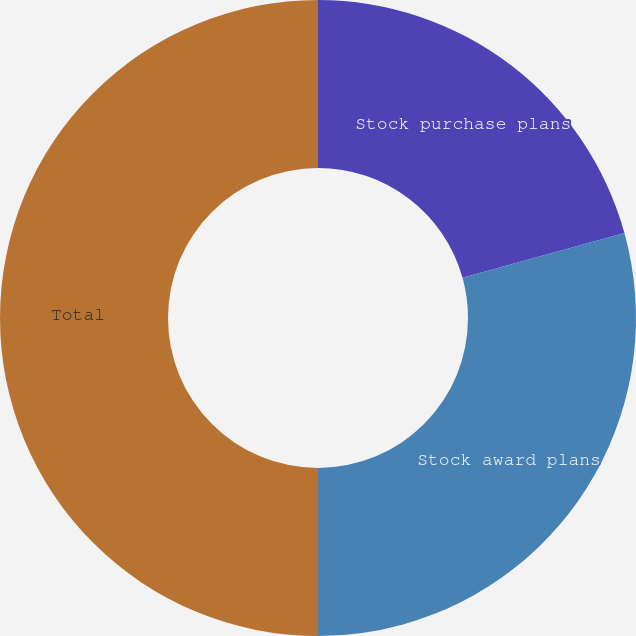<chart> <loc_0><loc_0><loc_500><loc_500><pie_chart><fcel>Stock purchase plans<fcel>Stock award plans<fcel>Total<nl><fcel>20.69%<fcel>29.31%<fcel>50.0%<nl></chart> 